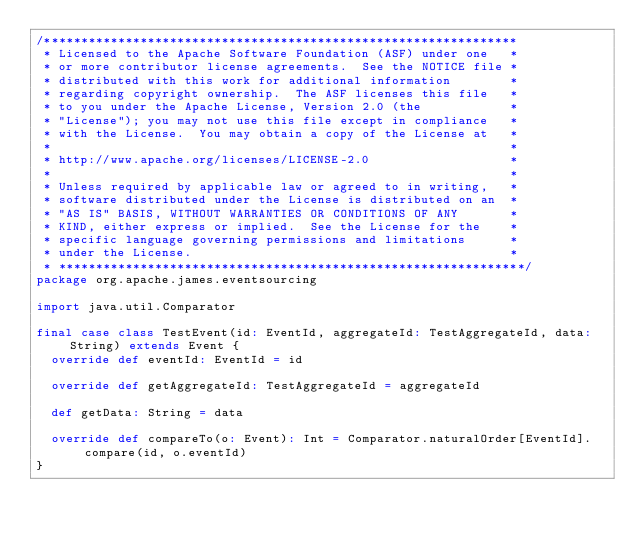<code> <loc_0><loc_0><loc_500><loc_500><_Scala_>/****************************************************************
 * Licensed to the Apache Software Foundation (ASF) under one   *
 * or more contributor license agreements.  See the NOTICE file *
 * distributed with this work for additional information        *
 * regarding copyright ownership.  The ASF licenses this file   *
 * to you under the Apache License, Version 2.0 (the            *
 * "License"); you may not use this file except in compliance   *
 * with the License.  You may obtain a copy of the License at   *
 *                                                              *
 * http://www.apache.org/licenses/LICENSE-2.0                   *
 *                                                              *
 * Unless required by applicable law or agreed to in writing,   *
 * software distributed under the License is distributed on an  *
 * "AS IS" BASIS, WITHOUT WARRANTIES OR CONDITIONS OF ANY       *
 * KIND, either express or implied.  See the License for the    *
 * specific language governing permissions and limitations      *
 * under the License.                                           *
 * ***************************************************************/
package org.apache.james.eventsourcing

import java.util.Comparator

final case class TestEvent(id: EventId, aggregateId: TestAggregateId, data: String) extends Event {
  override def eventId: EventId = id

  override def getAggregateId: TestAggregateId = aggregateId

  def getData: String = data

  override def compareTo(o: Event): Int = Comparator.naturalOrder[EventId].compare(id, o.eventId)
}</code> 